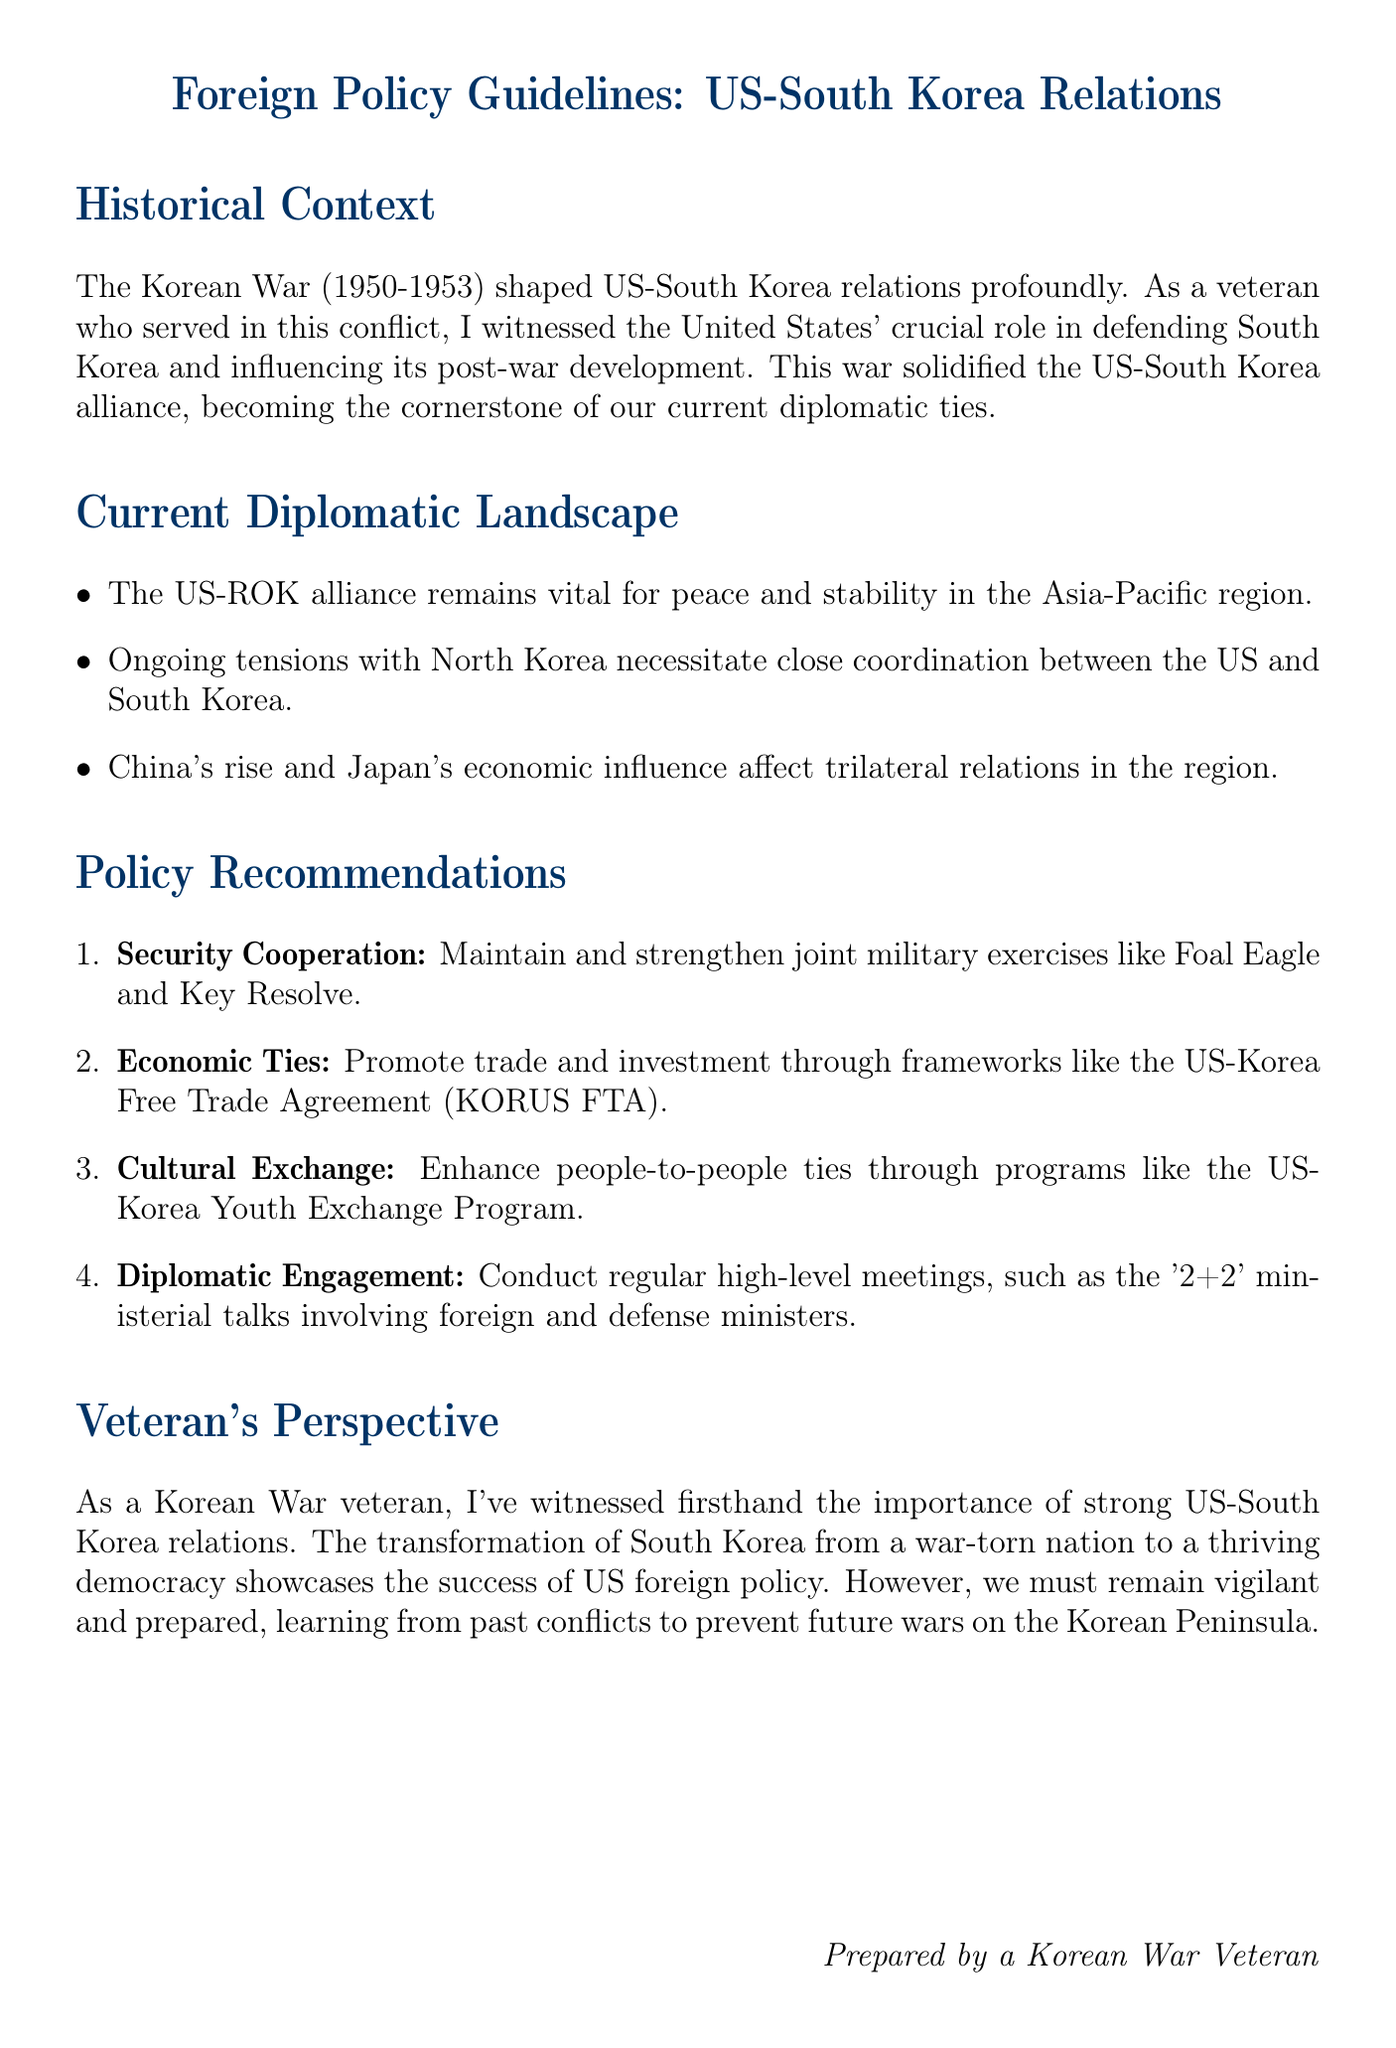What shaped US-South Korea relations? The document states that the Korean War (1950-1953) shaped US-South Korea relations profoundly.
Answer: Korean War What is a key focus of the US-ROK alliance? The document mentions that the alliance is vital for peace and stability in the Asia-Pacific region.
Answer: Peace and stability What joint military exercises are recommended to maintain security cooperation? The document lists Foal Eagle and Key Resolve as joint military exercises to maintain security cooperation.
Answer: Foal Eagle and Key Resolve What program is suggested for enhancing cultural exchange? The document refers to the US-Korea Youth Exchange Program for promoting cultural exchange.
Answer: US-Korea Youth Exchange Program Who would be involved in the '2+2' ministerial talks? The document specifies that the talks involve foreign and defense ministers.
Answer: Foreign and defense ministers What transformation does the document highlight about South Korea? It mentions South Korea's transformation from a war-torn nation to a thriving democracy.
Answer: Thriving democracy How many policy recommendations are listed in the document? The document enumerates four policy recommendations for maintaining relations with South Korea.
Answer: Four What historical experience does the author emphasize in the document? The author emphasizes the author's experience as a Korean War veteran in understanding the importance of strong US-South Korea relations.
Answer: Korean War veteran experience What does the document suggest regarding North Korea? It indicates that ongoing tensions with North Korea necessitate close coordination between the US and South Korea.
Answer: Close coordination What must the US and South Korea prepare to prevent, according to the document? The document advises that vigilance and preparedness are necessary to prevent future wars on the Korean Peninsula.
Answer: Future wars 